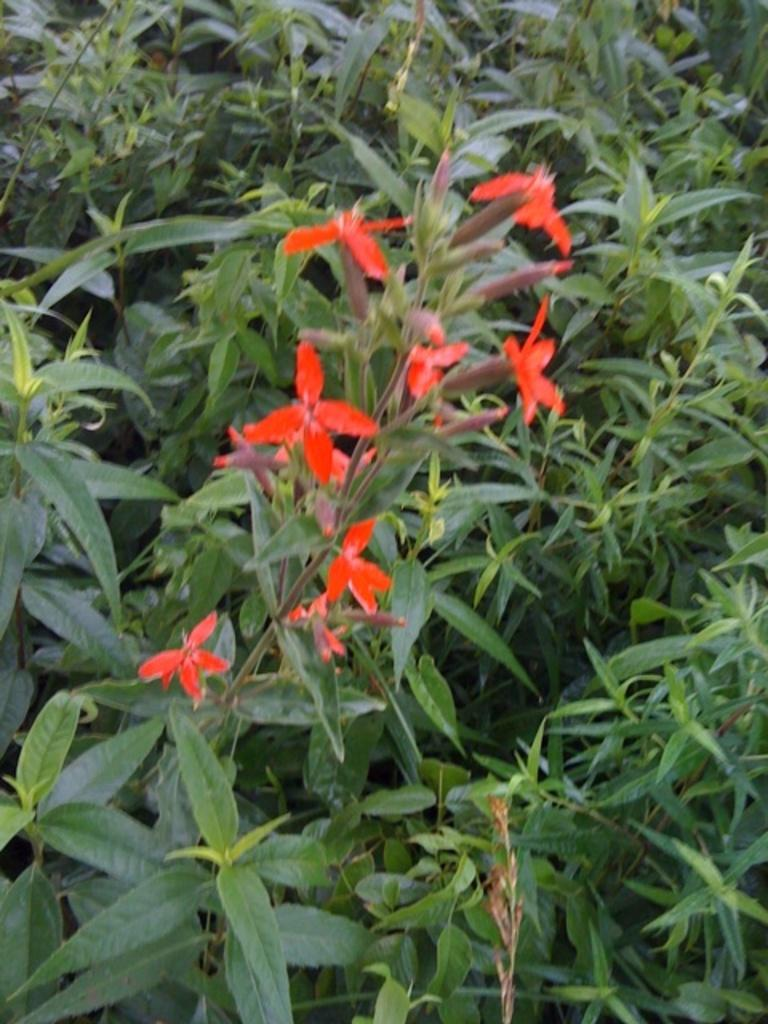What type of flowers can be seen in the image? There are red flowers in the image. How are the red flowers attached to the plant? The red flowers are on the stem of a plant. What is the surrounding environment of the plant with red flowers? The plant with red flowers is situated among other plants. Where can the toys be found in the image? There are no toys present in the image. Is the cemetery visible in the image? There is no cemetery present in the image. 